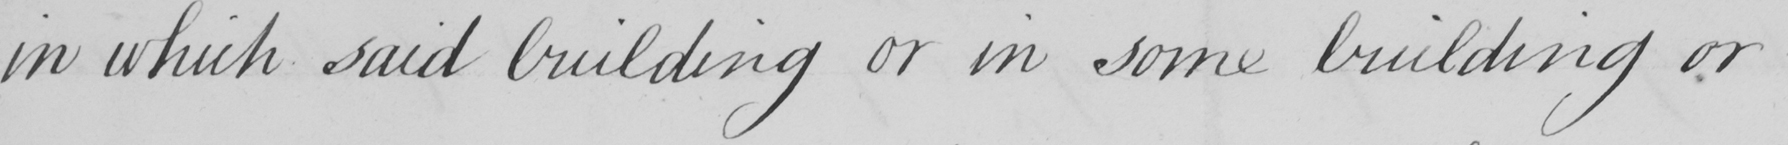Please transcribe the handwritten text in this image. in which said building or in some building or 